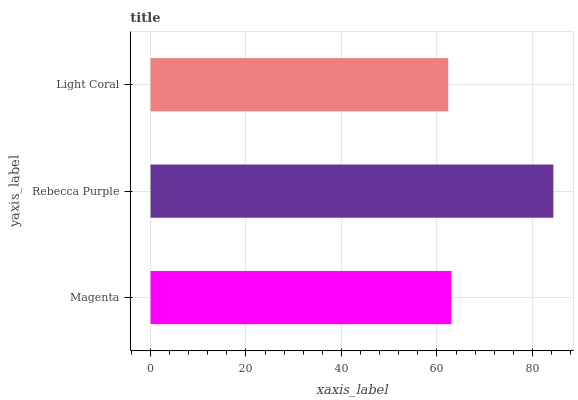Is Light Coral the minimum?
Answer yes or no. Yes. Is Rebecca Purple the maximum?
Answer yes or no. Yes. Is Rebecca Purple the minimum?
Answer yes or no. No. Is Light Coral the maximum?
Answer yes or no. No. Is Rebecca Purple greater than Light Coral?
Answer yes or no. Yes. Is Light Coral less than Rebecca Purple?
Answer yes or no. Yes. Is Light Coral greater than Rebecca Purple?
Answer yes or no. No. Is Rebecca Purple less than Light Coral?
Answer yes or no. No. Is Magenta the high median?
Answer yes or no. Yes. Is Magenta the low median?
Answer yes or no. Yes. Is Rebecca Purple the high median?
Answer yes or no. No. Is Light Coral the low median?
Answer yes or no. No. 